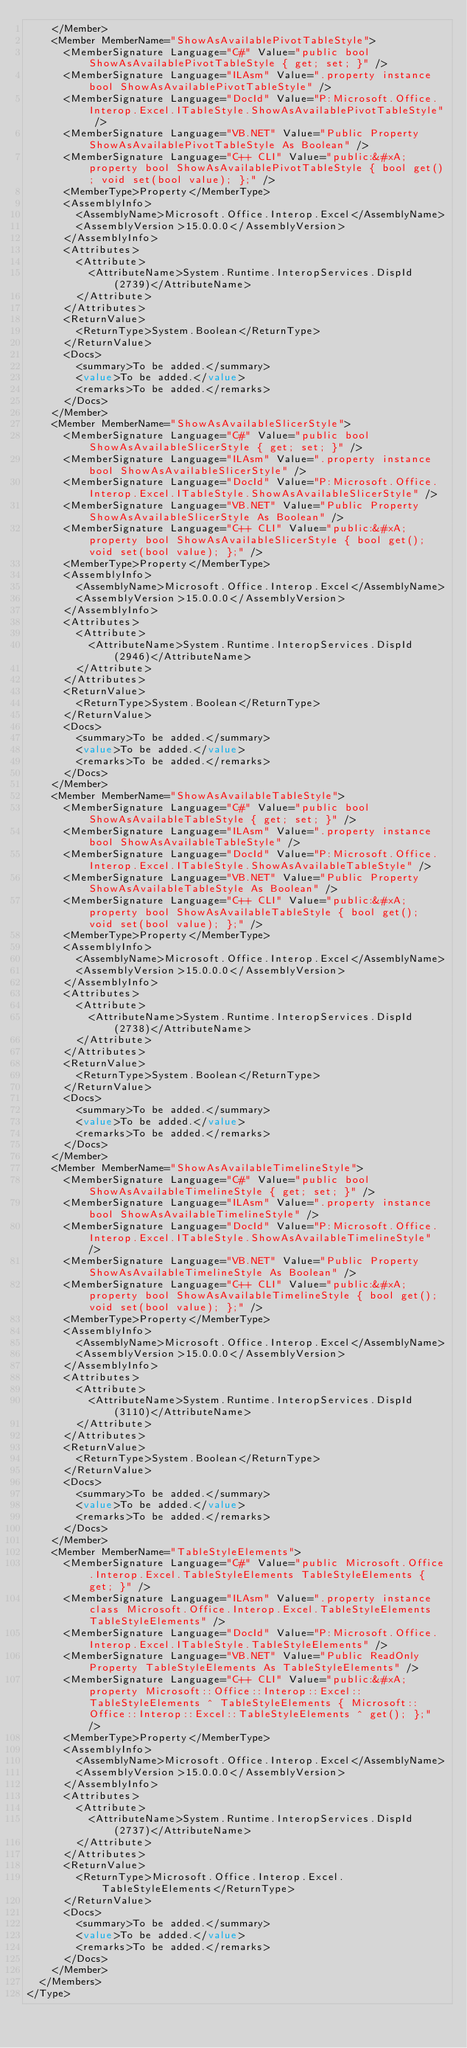Convert code to text. <code><loc_0><loc_0><loc_500><loc_500><_XML_>    </Member>
    <Member MemberName="ShowAsAvailablePivotTableStyle">
      <MemberSignature Language="C#" Value="public bool ShowAsAvailablePivotTableStyle { get; set; }" />
      <MemberSignature Language="ILAsm" Value=".property instance bool ShowAsAvailablePivotTableStyle" />
      <MemberSignature Language="DocId" Value="P:Microsoft.Office.Interop.Excel.ITableStyle.ShowAsAvailablePivotTableStyle" />
      <MemberSignature Language="VB.NET" Value="Public Property ShowAsAvailablePivotTableStyle As Boolean" />
      <MemberSignature Language="C++ CLI" Value="public:&#xA; property bool ShowAsAvailablePivotTableStyle { bool get(); void set(bool value); };" />
      <MemberType>Property</MemberType>
      <AssemblyInfo>
        <AssemblyName>Microsoft.Office.Interop.Excel</AssemblyName>
        <AssemblyVersion>15.0.0.0</AssemblyVersion>
      </AssemblyInfo>
      <Attributes>
        <Attribute>
          <AttributeName>System.Runtime.InteropServices.DispId(2739)</AttributeName>
        </Attribute>
      </Attributes>
      <ReturnValue>
        <ReturnType>System.Boolean</ReturnType>
      </ReturnValue>
      <Docs>
        <summary>To be added.</summary>
        <value>To be added.</value>
        <remarks>To be added.</remarks>
      </Docs>
    </Member>
    <Member MemberName="ShowAsAvailableSlicerStyle">
      <MemberSignature Language="C#" Value="public bool ShowAsAvailableSlicerStyle { get; set; }" />
      <MemberSignature Language="ILAsm" Value=".property instance bool ShowAsAvailableSlicerStyle" />
      <MemberSignature Language="DocId" Value="P:Microsoft.Office.Interop.Excel.ITableStyle.ShowAsAvailableSlicerStyle" />
      <MemberSignature Language="VB.NET" Value="Public Property ShowAsAvailableSlicerStyle As Boolean" />
      <MemberSignature Language="C++ CLI" Value="public:&#xA; property bool ShowAsAvailableSlicerStyle { bool get(); void set(bool value); };" />
      <MemberType>Property</MemberType>
      <AssemblyInfo>
        <AssemblyName>Microsoft.Office.Interop.Excel</AssemblyName>
        <AssemblyVersion>15.0.0.0</AssemblyVersion>
      </AssemblyInfo>
      <Attributes>
        <Attribute>
          <AttributeName>System.Runtime.InteropServices.DispId(2946)</AttributeName>
        </Attribute>
      </Attributes>
      <ReturnValue>
        <ReturnType>System.Boolean</ReturnType>
      </ReturnValue>
      <Docs>
        <summary>To be added.</summary>
        <value>To be added.</value>
        <remarks>To be added.</remarks>
      </Docs>
    </Member>
    <Member MemberName="ShowAsAvailableTableStyle">
      <MemberSignature Language="C#" Value="public bool ShowAsAvailableTableStyle { get; set; }" />
      <MemberSignature Language="ILAsm" Value=".property instance bool ShowAsAvailableTableStyle" />
      <MemberSignature Language="DocId" Value="P:Microsoft.Office.Interop.Excel.ITableStyle.ShowAsAvailableTableStyle" />
      <MemberSignature Language="VB.NET" Value="Public Property ShowAsAvailableTableStyle As Boolean" />
      <MemberSignature Language="C++ CLI" Value="public:&#xA; property bool ShowAsAvailableTableStyle { bool get(); void set(bool value); };" />
      <MemberType>Property</MemberType>
      <AssemblyInfo>
        <AssemblyName>Microsoft.Office.Interop.Excel</AssemblyName>
        <AssemblyVersion>15.0.0.0</AssemblyVersion>
      </AssemblyInfo>
      <Attributes>
        <Attribute>
          <AttributeName>System.Runtime.InteropServices.DispId(2738)</AttributeName>
        </Attribute>
      </Attributes>
      <ReturnValue>
        <ReturnType>System.Boolean</ReturnType>
      </ReturnValue>
      <Docs>
        <summary>To be added.</summary>
        <value>To be added.</value>
        <remarks>To be added.</remarks>
      </Docs>
    </Member>
    <Member MemberName="ShowAsAvailableTimelineStyle">
      <MemberSignature Language="C#" Value="public bool ShowAsAvailableTimelineStyle { get; set; }" />
      <MemberSignature Language="ILAsm" Value=".property instance bool ShowAsAvailableTimelineStyle" />
      <MemberSignature Language="DocId" Value="P:Microsoft.Office.Interop.Excel.ITableStyle.ShowAsAvailableTimelineStyle" />
      <MemberSignature Language="VB.NET" Value="Public Property ShowAsAvailableTimelineStyle As Boolean" />
      <MemberSignature Language="C++ CLI" Value="public:&#xA; property bool ShowAsAvailableTimelineStyle { bool get(); void set(bool value); };" />
      <MemberType>Property</MemberType>
      <AssemblyInfo>
        <AssemblyName>Microsoft.Office.Interop.Excel</AssemblyName>
        <AssemblyVersion>15.0.0.0</AssemblyVersion>
      </AssemblyInfo>
      <Attributes>
        <Attribute>
          <AttributeName>System.Runtime.InteropServices.DispId(3110)</AttributeName>
        </Attribute>
      </Attributes>
      <ReturnValue>
        <ReturnType>System.Boolean</ReturnType>
      </ReturnValue>
      <Docs>
        <summary>To be added.</summary>
        <value>To be added.</value>
        <remarks>To be added.</remarks>
      </Docs>
    </Member>
    <Member MemberName="TableStyleElements">
      <MemberSignature Language="C#" Value="public Microsoft.Office.Interop.Excel.TableStyleElements TableStyleElements { get; }" />
      <MemberSignature Language="ILAsm" Value=".property instance class Microsoft.Office.Interop.Excel.TableStyleElements TableStyleElements" />
      <MemberSignature Language="DocId" Value="P:Microsoft.Office.Interop.Excel.ITableStyle.TableStyleElements" />
      <MemberSignature Language="VB.NET" Value="Public ReadOnly Property TableStyleElements As TableStyleElements" />
      <MemberSignature Language="C++ CLI" Value="public:&#xA; property Microsoft::Office::Interop::Excel::TableStyleElements ^ TableStyleElements { Microsoft::Office::Interop::Excel::TableStyleElements ^ get(); };" />
      <MemberType>Property</MemberType>
      <AssemblyInfo>
        <AssemblyName>Microsoft.Office.Interop.Excel</AssemblyName>
        <AssemblyVersion>15.0.0.0</AssemblyVersion>
      </AssemblyInfo>
      <Attributes>
        <Attribute>
          <AttributeName>System.Runtime.InteropServices.DispId(2737)</AttributeName>
        </Attribute>
      </Attributes>
      <ReturnValue>
        <ReturnType>Microsoft.Office.Interop.Excel.TableStyleElements</ReturnType>
      </ReturnValue>
      <Docs>
        <summary>To be added.</summary>
        <value>To be added.</value>
        <remarks>To be added.</remarks>
      </Docs>
    </Member>
  </Members>
</Type></code> 